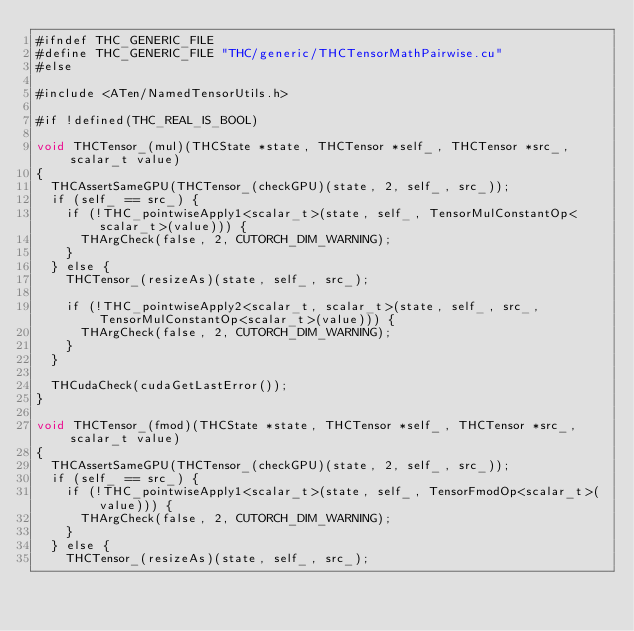<code> <loc_0><loc_0><loc_500><loc_500><_Cuda_>#ifndef THC_GENERIC_FILE
#define THC_GENERIC_FILE "THC/generic/THCTensorMathPairwise.cu"
#else

#include <ATen/NamedTensorUtils.h>

#if !defined(THC_REAL_IS_BOOL)

void THCTensor_(mul)(THCState *state, THCTensor *self_, THCTensor *src_, scalar_t value)
{
  THCAssertSameGPU(THCTensor_(checkGPU)(state, 2, self_, src_));
  if (self_ == src_) {
    if (!THC_pointwiseApply1<scalar_t>(state, self_, TensorMulConstantOp<scalar_t>(value))) {
      THArgCheck(false, 2, CUTORCH_DIM_WARNING);
    }
  } else {
    THCTensor_(resizeAs)(state, self_, src_);

    if (!THC_pointwiseApply2<scalar_t, scalar_t>(state, self_, src_, TensorMulConstantOp<scalar_t>(value))) {
      THArgCheck(false, 2, CUTORCH_DIM_WARNING);
    }
  }

  THCudaCheck(cudaGetLastError());
}

void THCTensor_(fmod)(THCState *state, THCTensor *self_, THCTensor *src_, scalar_t value)
{
  THCAssertSameGPU(THCTensor_(checkGPU)(state, 2, self_, src_));
  if (self_ == src_) {
    if (!THC_pointwiseApply1<scalar_t>(state, self_, TensorFmodOp<scalar_t>(value))) {
      THArgCheck(false, 2, CUTORCH_DIM_WARNING);
    }
  } else {
    THCTensor_(resizeAs)(state, self_, src_);
</code> 